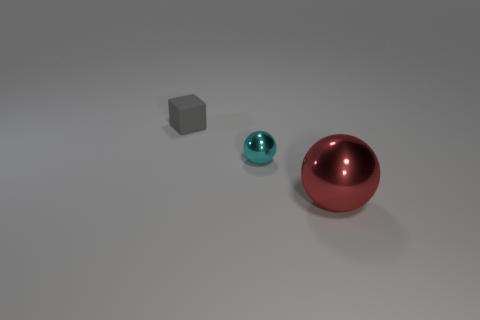What number of other things are the same shape as the gray object?
Provide a succinct answer. 0. What size is the metallic object behind the ball that is to the right of the small thing in front of the small gray thing?
Offer a very short reply. Small. What number of objects are either purple things or metal things on the left side of the big red shiny thing?
Your answer should be very brief. 1. What is the color of the matte block?
Provide a succinct answer. Gray. There is a tiny object that is right of the gray cube; what is its color?
Ensure brevity in your answer.  Cyan. There is a tiny thing right of the gray matte block; how many red metal things are in front of it?
Ensure brevity in your answer.  1. Does the cube have the same size as the thing that is to the right of the small shiny sphere?
Offer a very short reply. No. Is there a shiny ball of the same size as the red object?
Offer a terse response. No. How many objects are small gray things or small shiny things?
Make the answer very short. 2. There is a metal object that is right of the cyan metallic ball; is it the same size as the ball to the left of the large red sphere?
Your answer should be compact. No. 